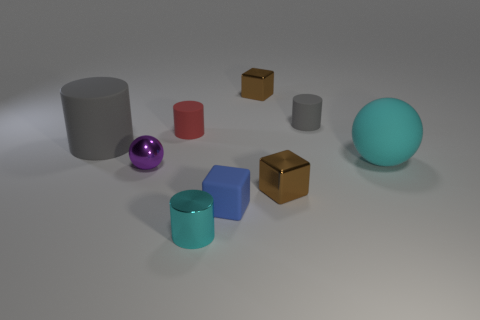How big is the brown shiny object that is behind the large rubber cylinder?
Your answer should be very brief. Small. Are there more matte cylinders than blue rubber blocks?
Provide a short and direct response. Yes. What is the tiny red cylinder made of?
Ensure brevity in your answer.  Rubber. How many other objects are there of the same material as the purple object?
Give a very brief answer. 3. How many large cyan matte objects are there?
Provide a succinct answer. 1. There is a purple object that is the same shape as the big cyan thing; what is its material?
Your response must be concise. Metal. Is the material of the gray cylinder that is to the left of the metallic sphere the same as the purple sphere?
Provide a short and direct response. No. Is the number of blue blocks that are to the right of the small purple thing greater than the number of tiny cyan metallic objects that are behind the tiny blue object?
Keep it short and to the point. Yes. What is the size of the purple ball?
Give a very brief answer. Small. There is a blue thing that is the same material as the big sphere; what is its shape?
Give a very brief answer. Cube. 